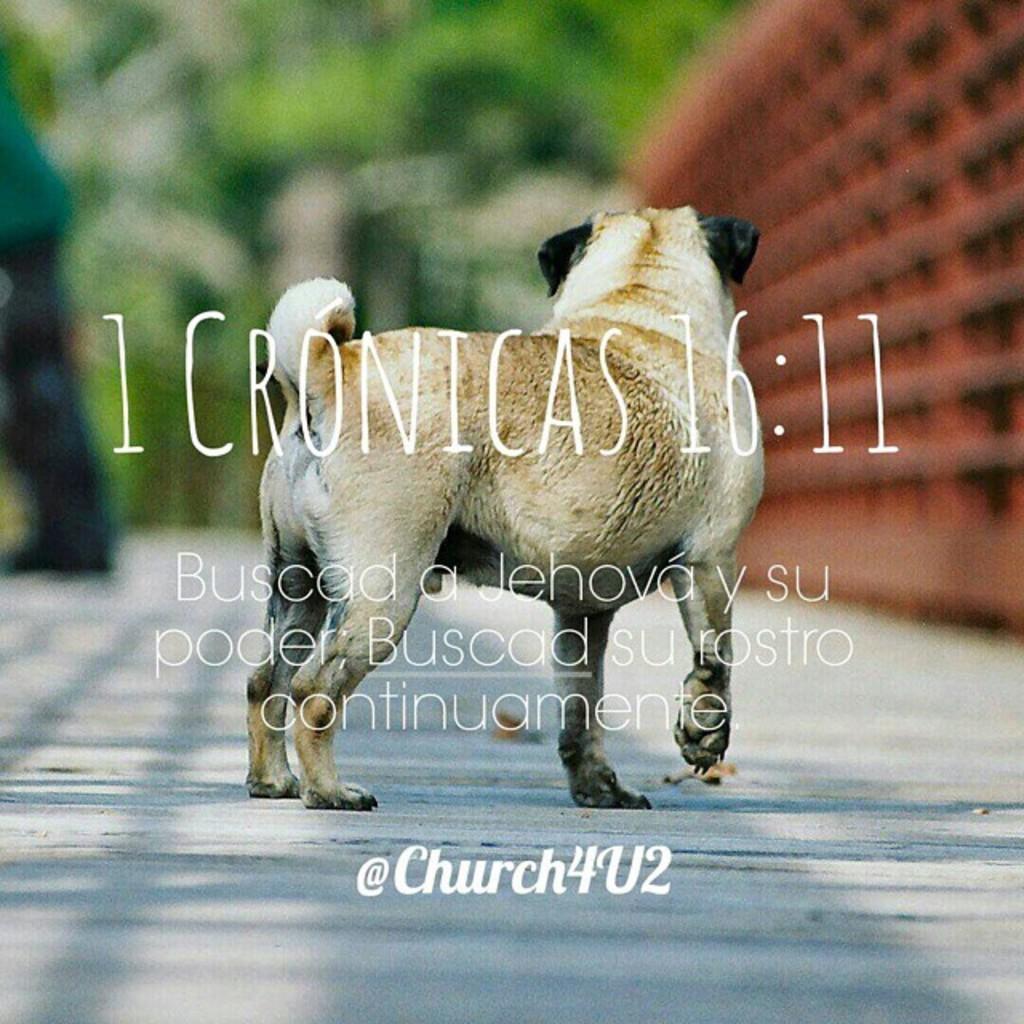Can you describe this image briefly? In this image there is a poster. There is a dog standing on the floor. Front side of the image there is some text. Background is blurry. 